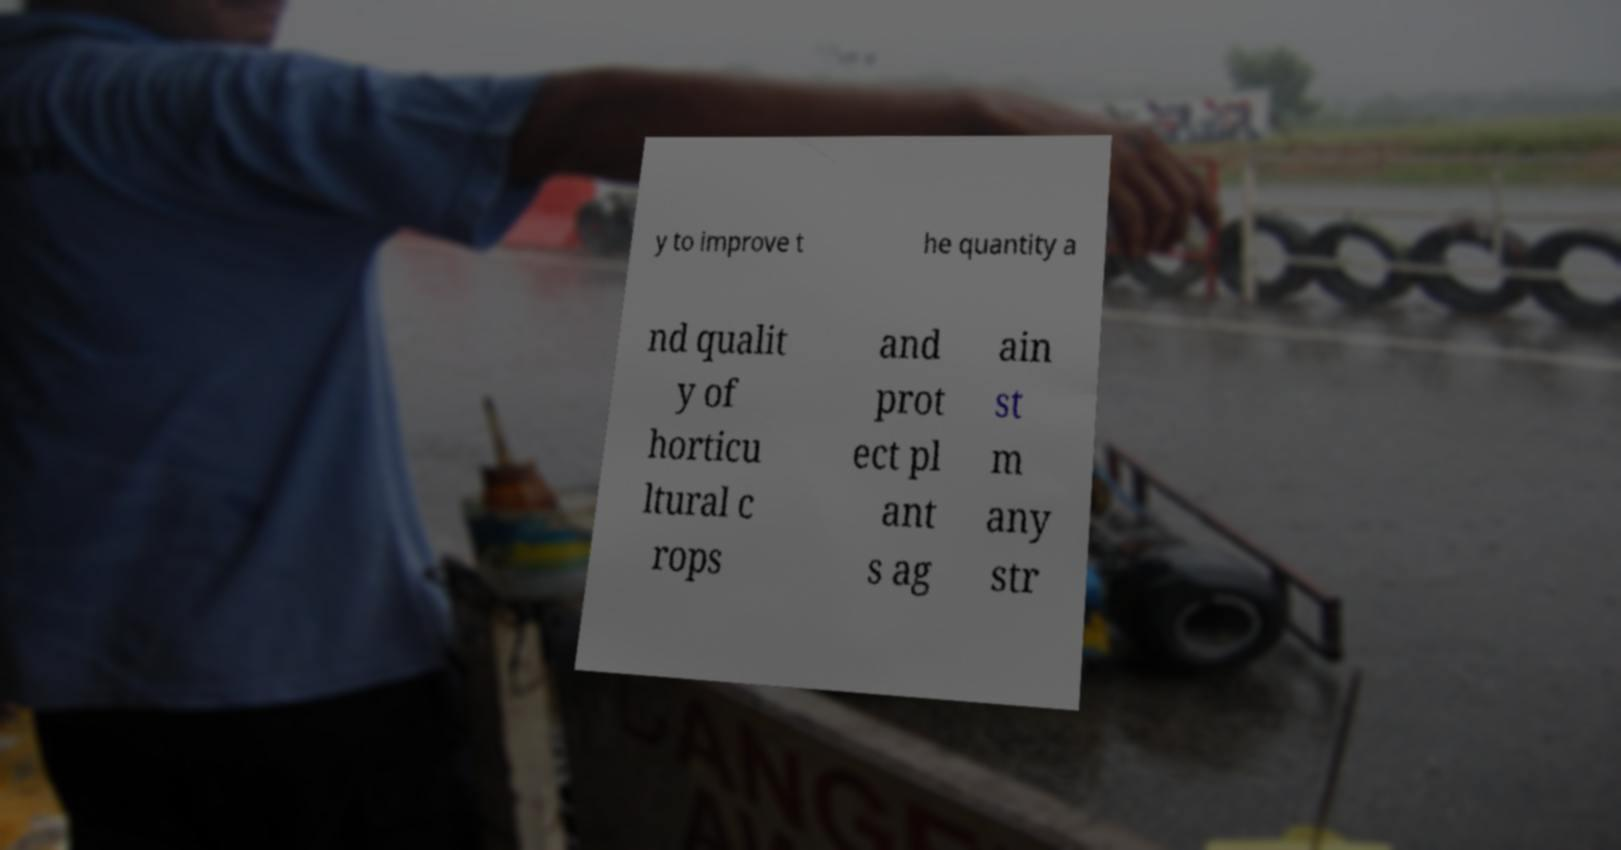I need the written content from this picture converted into text. Can you do that? y to improve t he quantity a nd qualit y of horticu ltural c rops and prot ect pl ant s ag ain st m any str 